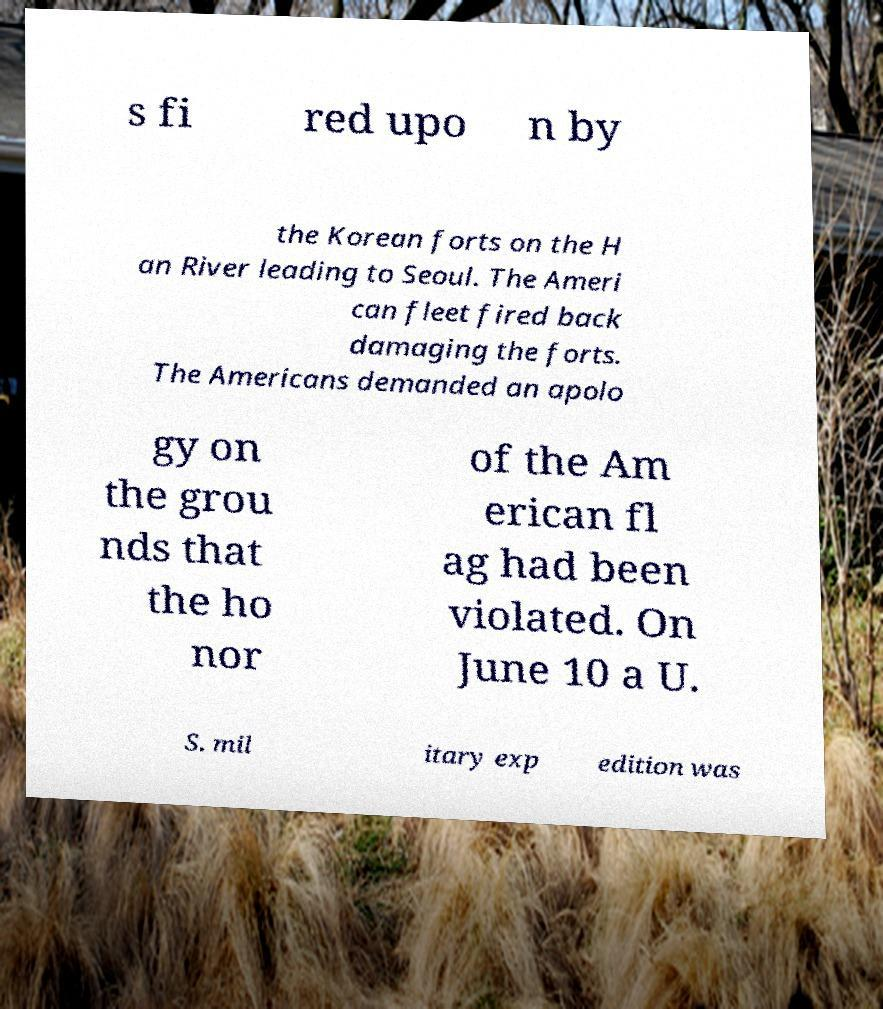Please identify and transcribe the text found in this image. s fi red upo n by the Korean forts on the H an River leading to Seoul. The Ameri can fleet fired back damaging the forts. The Americans demanded an apolo gy on the grou nds that the ho nor of the Am erican fl ag had been violated. On June 10 a U. S. mil itary exp edition was 